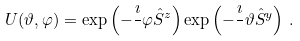Convert formula to latex. <formula><loc_0><loc_0><loc_500><loc_500>U ( \vartheta , \varphi ) = \exp \left ( - \frac { \imath } { } \varphi \hat { S } ^ { z } \right ) \exp \left ( - \frac { \imath } { } \vartheta \hat { S } ^ { y } \right ) \, .</formula> 